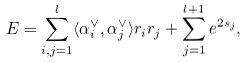<formula> <loc_0><loc_0><loc_500><loc_500>E = \sum _ { i , j = 1 } ^ { l } \langle \alpha _ { i } ^ { \vee } , \alpha _ { j } ^ { \vee } \rangle r _ { i } r _ { j } + \sum _ { j = 1 } ^ { l + 1 } e ^ { 2 s _ { j } } ,</formula> 